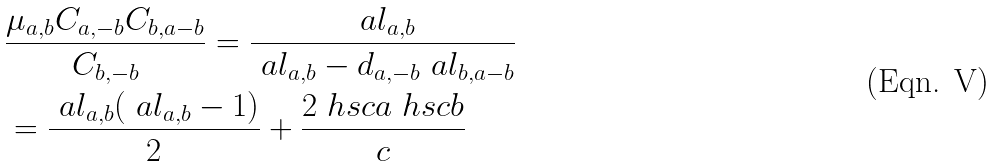Convert formula to latex. <formula><loc_0><loc_0><loc_500><loc_500>& \frac { \mu _ { a , b } C _ { a , - b } C _ { b , a - b } } { C _ { b , - b } } = \frac { \ a l _ { a , b } } { \ a l _ { a , b } - d _ { a , - b } \ a l _ { b , a - b } } \\ & = \frac { \ a l _ { a , b } ( \ a l _ { a , b } - 1 ) } { 2 } + \frac { 2 \ h s c { a } \ h s c { b } } { c }</formula> 